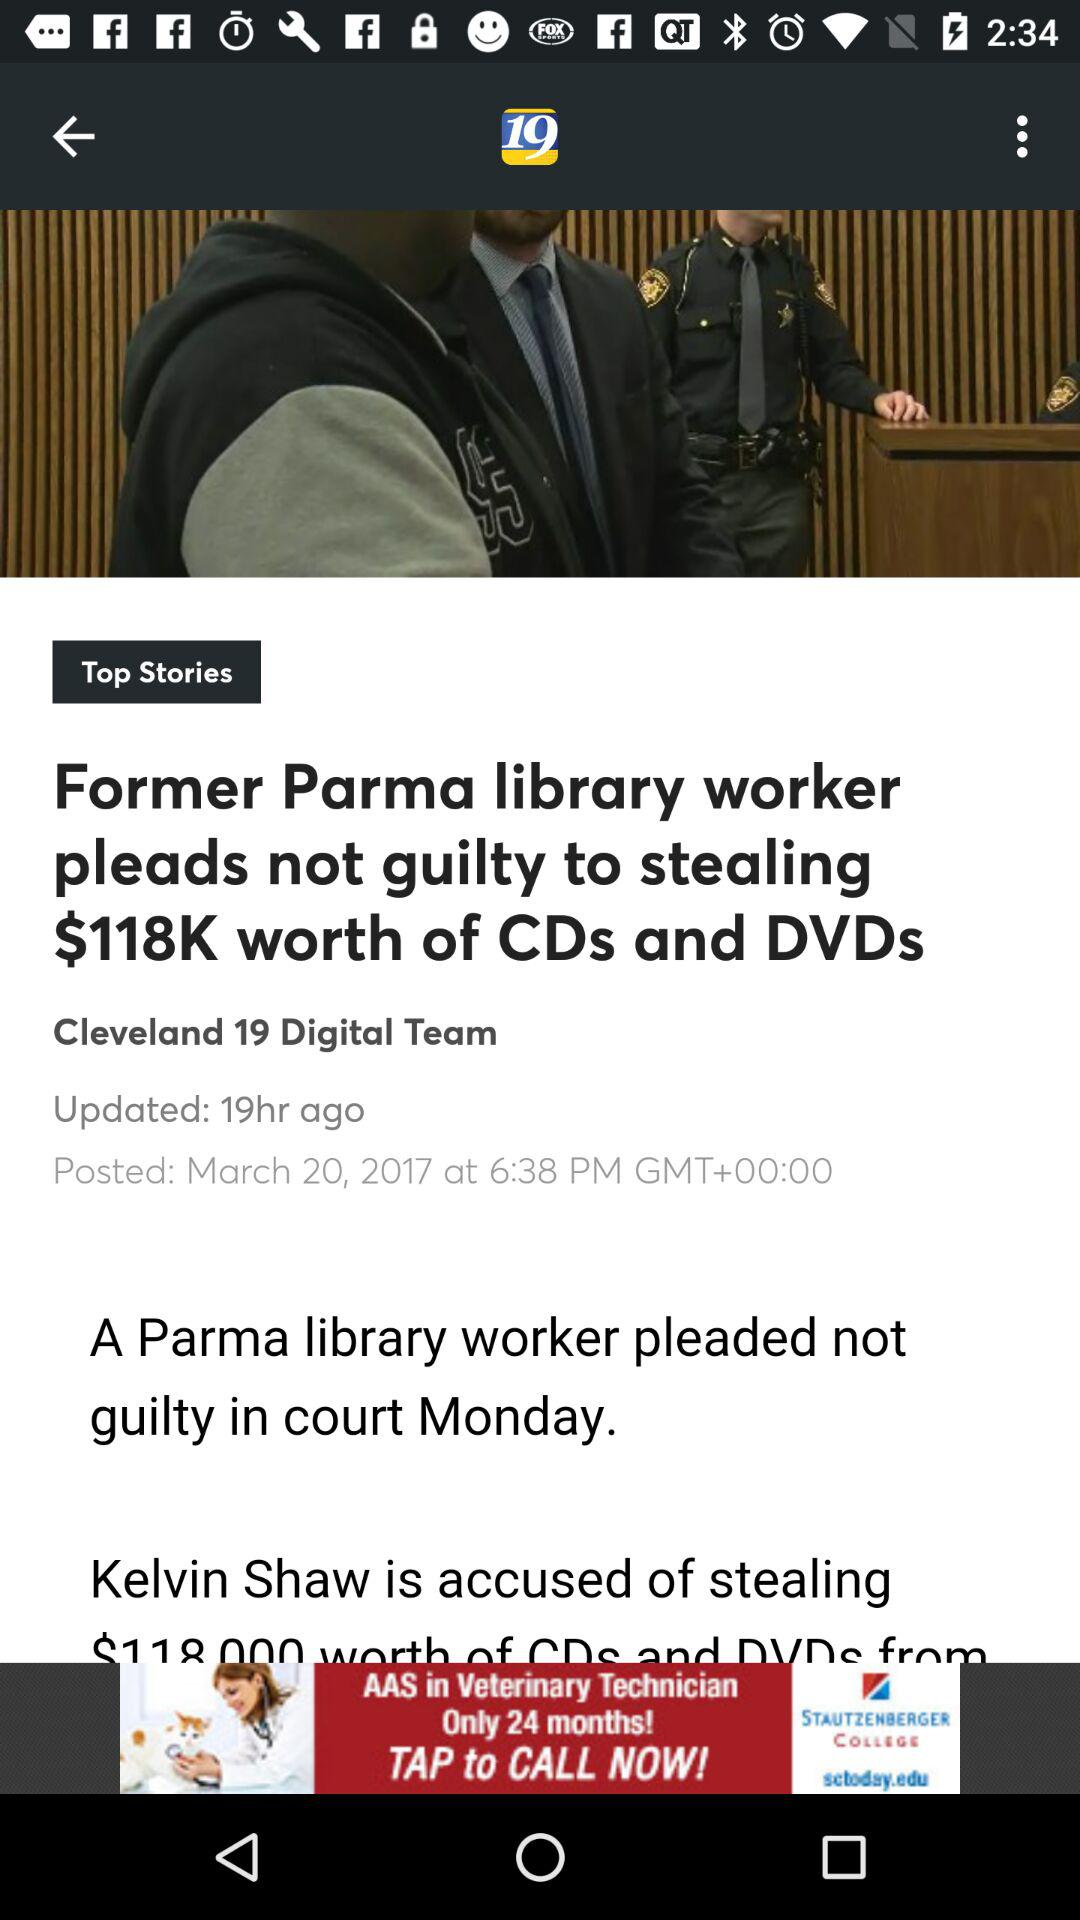At what time and date was the news about the former Parma library worker posted? It was posted on March 20, 2017 at 6:38 PM GMT +00:00. 